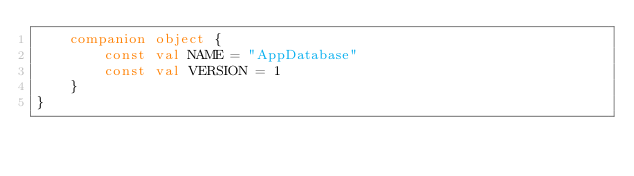<code> <loc_0><loc_0><loc_500><loc_500><_Kotlin_>    companion object {
        const val NAME = "AppDatabase"
        const val VERSION = 1
    }
}</code> 